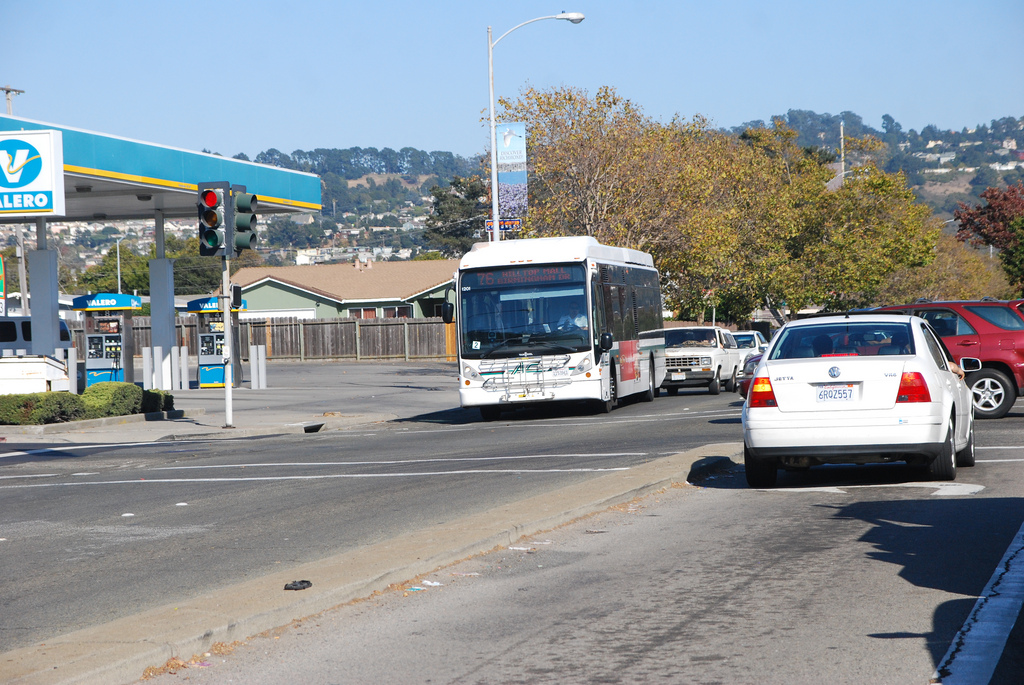Which side is the fence on? A wooden fence is present on the left side of the image, running along the sidewalk adjacent to the road. 